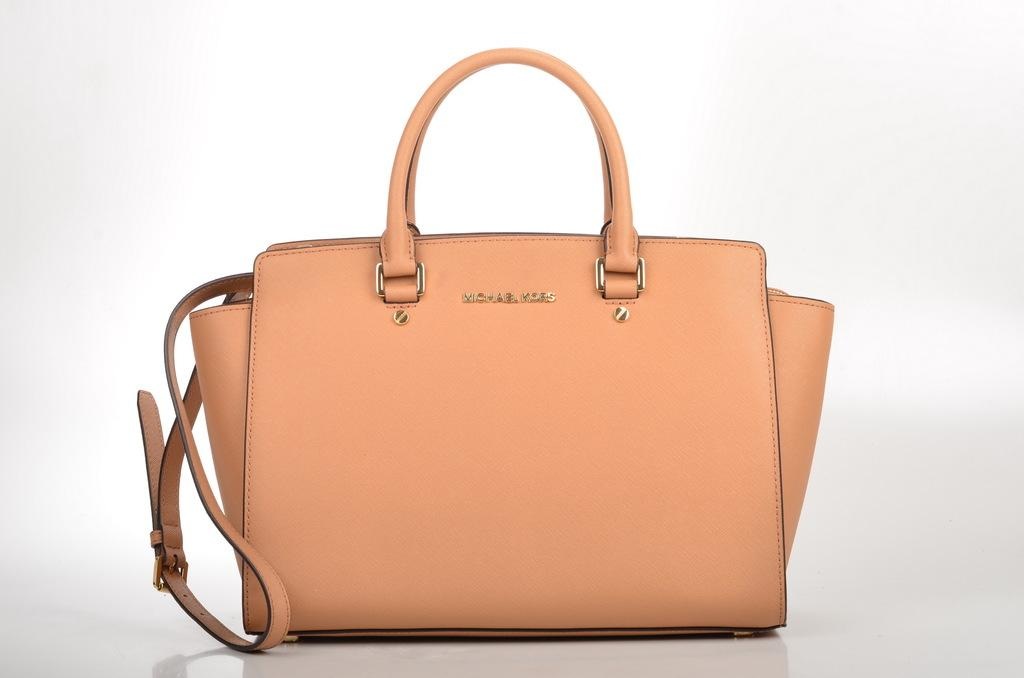What type of bag is visible in the image? There is an orange bag in the image. What color is the background of the image? The background of the image is white. Are there any giants wearing trousers in the image? There are no giants or trousers present in the image. What type of knowledge can be gained from the image? The image provides information about the color and type of bag, as well as the background color. However, it does not convey any specific knowledge beyond these visual details. 